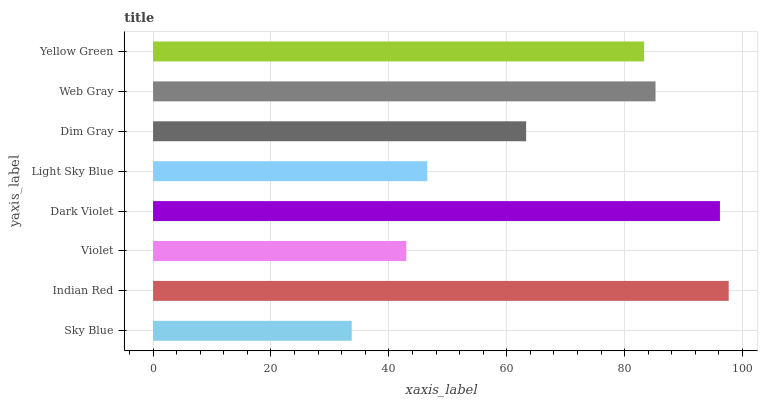Is Sky Blue the minimum?
Answer yes or no. Yes. Is Indian Red the maximum?
Answer yes or no. Yes. Is Violet the minimum?
Answer yes or no. No. Is Violet the maximum?
Answer yes or no. No. Is Indian Red greater than Violet?
Answer yes or no. Yes. Is Violet less than Indian Red?
Answer yes or no. Yes. Is Violet greater than Indian Red?
Answer yes or no. No. Is Indian Red less than Violet?
Answer yes or no. No. Is Yellow Green the high median?
Answer yes or no. Yes. Is Dim Gray the low median?
Answer yes or no. Yes. Is Violet the high median?
Answer yes or no. No. Is Dark Violet the low median?
Answer yes or no. No. 